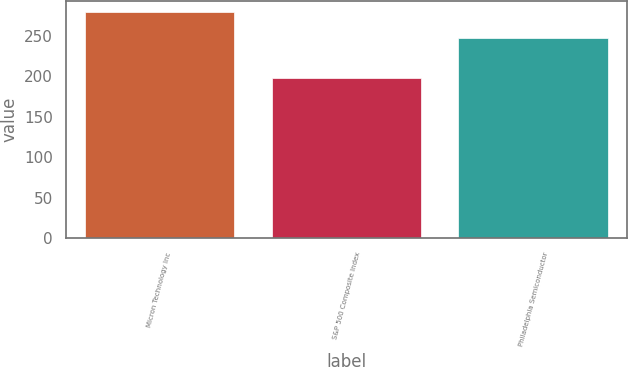Convert chart. <chart><loc_0><loc_0><loc_500><loc_500><bar_chart><fcel>Micron Technology Inc<fcel>S&P 500 Composite Index<fcel>Philadelphia Semiconductor<nl><fcel>279<fcel>198<fcel>247<nl></chart> 